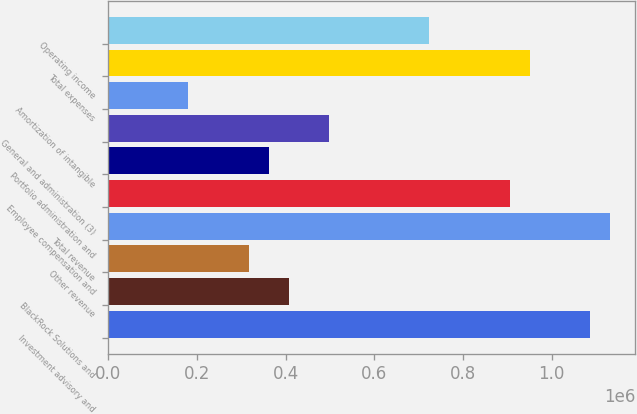<chart> <loc_0><loc_0><loc_500><loc_500><bar_chart><fcel>Investment advisory and<fcel>BlackRock Solutions and<fcel>Other revenue<fcel>Total revenue<fcel>Employee compensation and<fcel>Portfolio administration and<fcel>General and administration (3)<fcel>Amortization of intangible<fcel>Total expenses<fcel>Operating income<nl><fcel>1.08644e+06<fcel>407414<fcel>316878<fcel>1.1317e+06<fcel>905363<fcel>362146<fcel>497950<fcel>181074<fcel>950631<fcel>724290<nl></chart> 